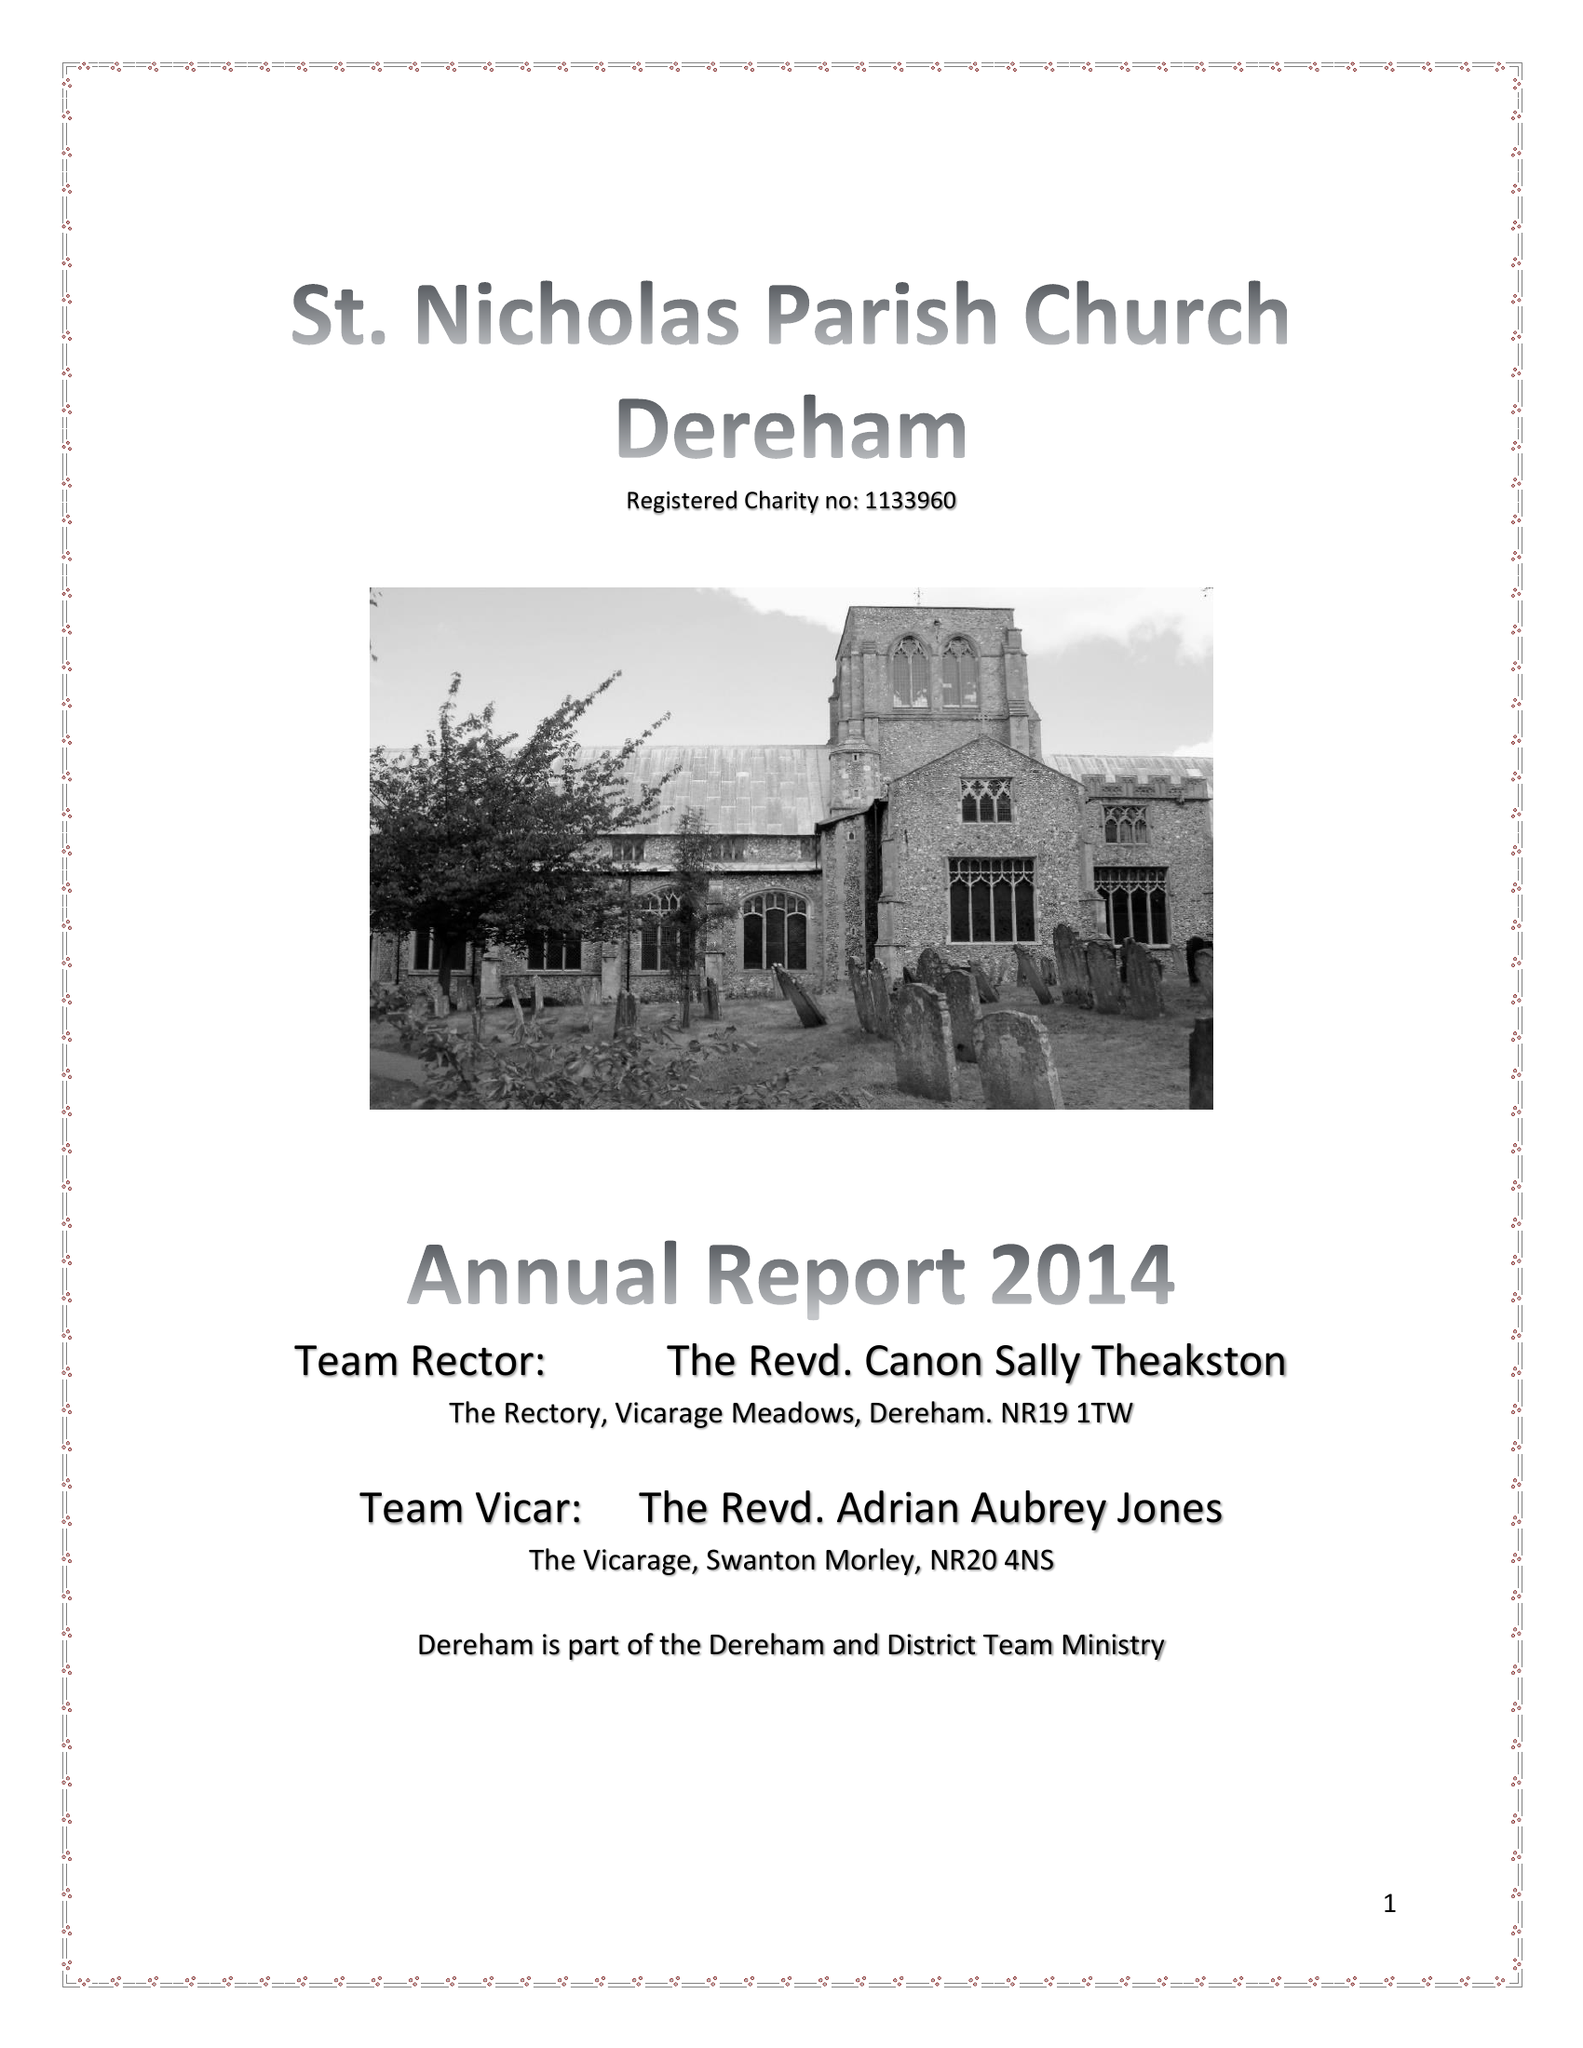What is the value for the income_annually_in_british_pounds?
Answer the question using a single word or phrase. 118245.00 